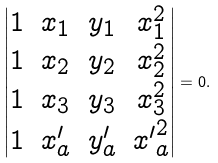<formula> <loc_0><loc_0><loc_500><loc_500>\left | \begin{matrix} 1 & x _ { 1 } & y _ { 1 } & x _ { 1 } ^ { 2 } \\ 1 & x _ { 2 } & y _ { 2 } & x _ { 2 } ^ { 2 } \\ 1 & x _ { 3 } & y _ { 3 } & x _ { 3 } ^ { 2 } \\ 1 & x ^ { \prime } _ { a } & y ^ { \prime } _ { a } & { x ^ { \prime } } _ { a } ^ { 2 } \\ \end{matrix} \right | = 0 .</formula> 